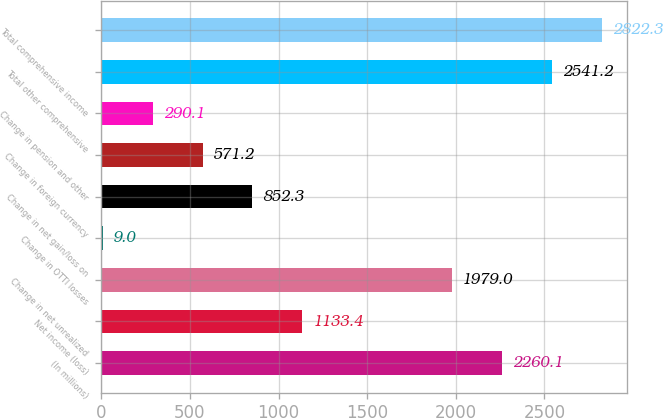<chart> <loc_0><loc_0><loc_500><loc_500><bar_chart><fcel>(In millions)<fcel>Net income (loss)<fcel>Change in net unrealized<fcel>Change in OTTI losses<fcel>Change in net gain/loss on<fcel>Change in foreign currency<fcel>Change in pension and other<fcel>Total other comprehensive<fcel>Total comprehensive income<nl><fcel>2260.1<fcel>1133.4<fcel>1979<fcel>9<fcel>852.3<fcel>571.2<fcel>290.1<fcel>2541.2<fcel>2822.3<nl></chart> 